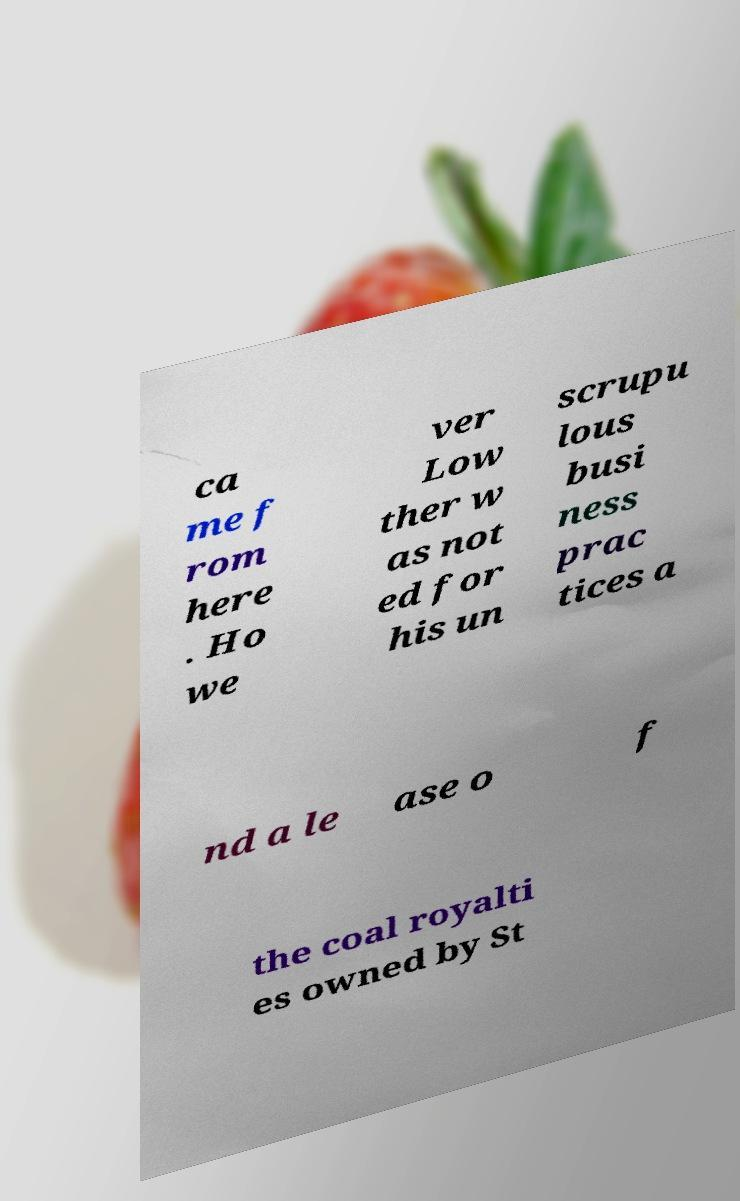Please identify and transcribe the text found in this image. ca me f rom here . Ho we ver Low ther w as not ed for his un scrupu lous busi ness prac tices a nd a le ase o f the coal royalti es owned by St 